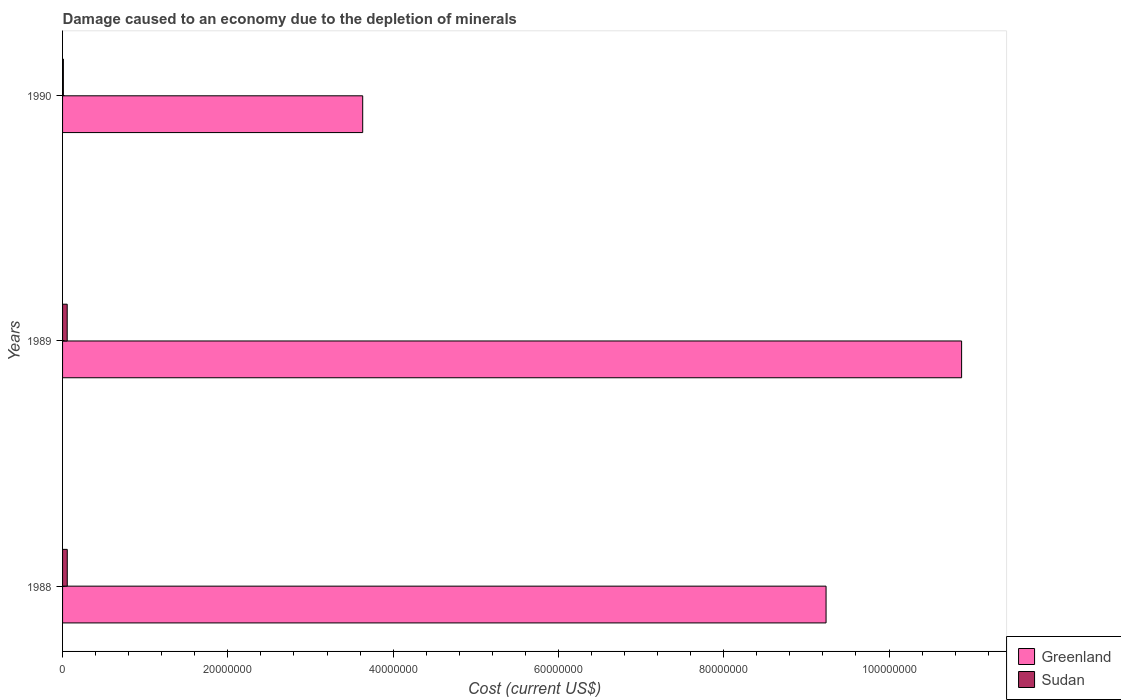Are the number of bars per tick equal to the number of legend labels?
Offer a terse response. Yes. Are the number of bars on each tick of the Y-axis equal?
Your response must be concise. Yes. How many bars are there on the 1st tick from the top?
Offer a very short reply. 2. What is the label of the 3rd group of bars from the top?
Your response must be concise. 1988. In how many cases, is the number of bars for a given year not equal to the number of legend labels?
Make the answer very short. 0. What is the cost of damage caused due to the depletion of minerals in Sudan in 1990?
Ensure brevity in your answer.  9.84e+04. Across all years, what is the maximum cost of damage caused due to the depletion of minerals in Greenland?
Ensure brevity in your answer.  1.09e+08. Across all years, what is the minimum cost of damage caused due to the depletion of minerals in Sudan?
Offer a terse response. 9.84e+04. What is the total cost of damage caused due to the depletion of minerals in Sudan in the graph?
Offer a very short reply. 1.23e+06. What is the difference between the cost of damage caused due to the depletion of minerals in Greenland in 1988 and that in 1989?
Give a very brief answer. -1.64e+07. What is the difference between the cost of damage caused due to the depletion of minerals in Greenland in 1990 and the cost of damage caused due to the depletion of minerals in Sudan in 1988?
Keep it short and to the point. 3.57e+07. What is the average cost of damage caused due to the depletion of minerals in Greenland per year?
Provide a short and direct response. 7.92e+07. In the year 1988, what is the difference between the cost of damage caused due to the depletion of minerals in Sudan and cost of damage caused due to the depletion of minerals in Greenland?
Give a very brief answer. -9.18e+07. In how many years, is the cost of damage caused due to the depletion of minerals in Sudan greater than 84000000 US$?
Offer a terse response. 0. What is the ratio of the cost of damage caused due to the depletion of minerals in Greenland in 1989 to that in 1990?
Offer a terse response. 3. What is the difference between the highest and the second highest cost of damage caused due to the depletion of minerals in Greenland?
Ensure brevity in your answer.  1.64e+07. What is the difference between the highest and the lowest cost of damage caused due to the depletion of minerals in Greenland?
Offer a very short reply. 7.25e+07. What does the 2nd bar from the top in 1990 represents?
Your response must be concise. Greenland. What does the 1st bar from the bottom in 1989 represents?
Make the answer very short. Greenland. Are all the bars in the graph horizontal?
Provide a short and direct response. Yes. Does the graph contain grids?
Your response must be concise. No. How are the legend labels stacked?
Your answer should be compact. Vertical. What is the title of the graph?
Keep it short and to the point. Damage caused to an economy due to the depletion of minerals. What is the label or title of the X-axis?
Provide a succinct answer. Cost (current US$). What is the label or title of the Y-axis?
Keep it short and to the point. Years. What is the Cost (current US$) of Greenland in 1988?
Offer a very short reply. 9.24e+07. What is the Cost (current US$) in Sudan in 1988?
Give a very brief answer. 5.68e+05. What is the Cost (current US$) in Greenland in 1989?
Ensure brevity in your answer.  1.09e+08. What is the Cost (current US$) in Sudan in 1989?
Offer a very short reply. 5.61e+05. What is the Cost (current US$) of Greenland in 1990?
Give a very brief answer. 3.63e+07. What is the Cost (current US$) in Sudan in 1990?
Make the answer very short. 9.84e+04. Across all years, what is the maximum Cost (current US$) of Greenland?
Provide a succinct answer. 1.09e+08. Across all years, what is the maximum Cost (current US$) of Sudan?
Give a very brief answer. 5.68e+05. Across all years, what is the minimum Cost (current US$) of Greenland?
Offer a very short reply. 3.63e+07. Across all years, what is the minimum Cost (current US$) in Sudan?
Provide a succinct answer. 9.84e+04. What is the total Cost (current US$) of Greenland in the graph?
Your response must be concise. 2.37e+08. What is the total Cost (current US$) in Sudan in the graph?
Make the answer very short. 1.23e+06. What is the difference between the Cost (current US$) of Greenland in 1988 and that in 1989?
Provide a short and direct response. -1.64e+07. What is the difference between the Cost (current US$) in Sudan in 1988 and that in 1989?
Provide a succinct answer. 7504.74. What is the difference between the Cost (current US$) of Greenland in 1988 and that in 1990?
Provide a succinct answer. 5.61e+07. What is the difference between the Cost (current US$) of Sudan in 1988 and that in 1990?
Provide a succinct answer. 4.70e+05. What is the difference between the Cost (current US$) of Greenland in 1989 and that in 1990?
Keep it short and to the point. 7.25e+07. What is the difference between the Cost (current US$) of Sudan in 1989 and that in 1990?
Offer a very short reply. 4.62e+05. What is the difference between the Cost (current US$) of Greenland in 1988 and the Cost (current US$) of Sudan in 1989?
Provide a succinct answer. 9.18e+07. What is the difference between the Cost (current US$) in Greenland in 1988 and the Cost (current US$) in Sudan in 1990?
Provide a succinct answer. 9.23e+07. What is the difference between the Cost (current US$) of Greenland in 1989 and the Cost (current US$) of Sudan in 1990?
Your answer should be compact. 1.09e+08. What is the average Cost (current US$) in Greenland per year?
Keep it short and to the point. 7.92e+07. What is the average Cost (current US$) of Sudan per year?
Offer a terse response. 4.09e+05. In the year 1988, what is the difference between the Cost (current US$) in Greenland and Cost (current US$) in Sudan?
Offer a terse response. 9.18e+07. In the year 1989, what is the difference between the Cost (current US$) of Greenland and Cost (current US$) of Sudan?
Keep it short and to the point. 1.08e+08. In the year 1990, what is the difference between the Cost (current US$) of Greenland and Cost (current US$) of Sudan?
Your answer should be compact. 3.62e+07. What is the ratio of the Cost (current US$) of Greenland in 1988 to that in 1989?
Provide a succinct answer. 0.85. What is the ratio of the Cost (current US$) in Sudan in 1988 to that in 1989?
Give a very brief answer. 1.01. What is the ratio of the Cost (current US$) in Greenland in 1988 to that in 1990?
Offer a terse response. 2.54. What is the ratio of the Cost (current US$) of Sudan in 1988 to that in 1990?
Your answer should be compact. 5.77. What is the ratio of the Cost (current US$) of Greenland in 1989 to that in 1990?
Make the answer very short. 3. What is the ratio of the Cost (current US$) in Sudan in 1989 to that in 1990?
Your answer should be compact. 5.7. What is the difference between the highest and the second highest Cost (current US$) of Greenland?
Your answer should be compact. 1.64e+07. What is the difference between the highest and the second highest Cost (current US$) in Sudan?
Make the answer very short. 7504.74. What is the difference between the highest and the lowest Cost (current US$) of Greenland?
Give a very brief answer. 7.25e+07. What is the difference between the highest and the lowest Cost (current US$) of Sudan?
Keep it short and to the point. 4.70e+05. 